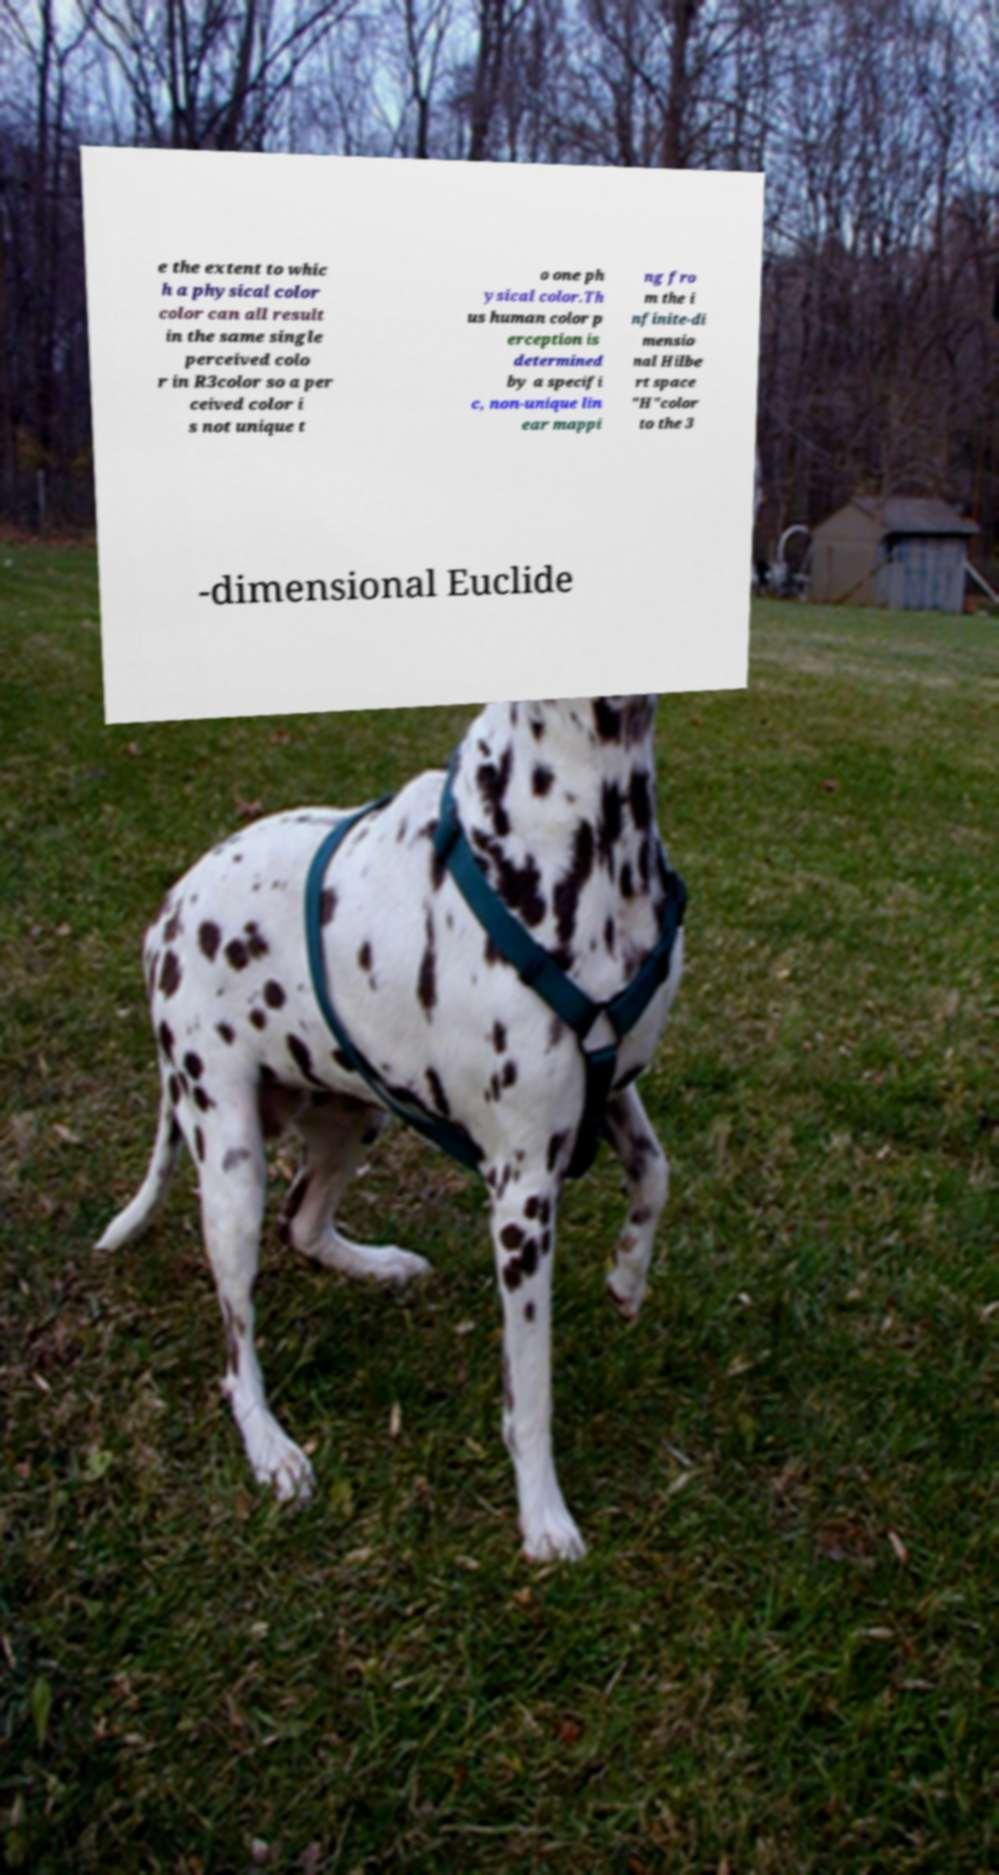I need the written content from this picture converted into text. Can you do that? e the extent to whic h a physical color color can all result in the same single perceived colo r in R3color so a per ceived color i s not unique t o one ph ysical color.Th us human color p erception is determined by a specifi c, non-unique lin ear mappi ng fro m the i nfinite-di mensio nal Hilbe rt space "H"color to the 3 -dimensional Euclide 